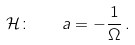Convert formula to latex. <formula><loc_0><loc_0><loc_500><loc_500>\mathcal { H } \colon \quad a = - \frac { 1 } { \Omega } \, .</formula> 